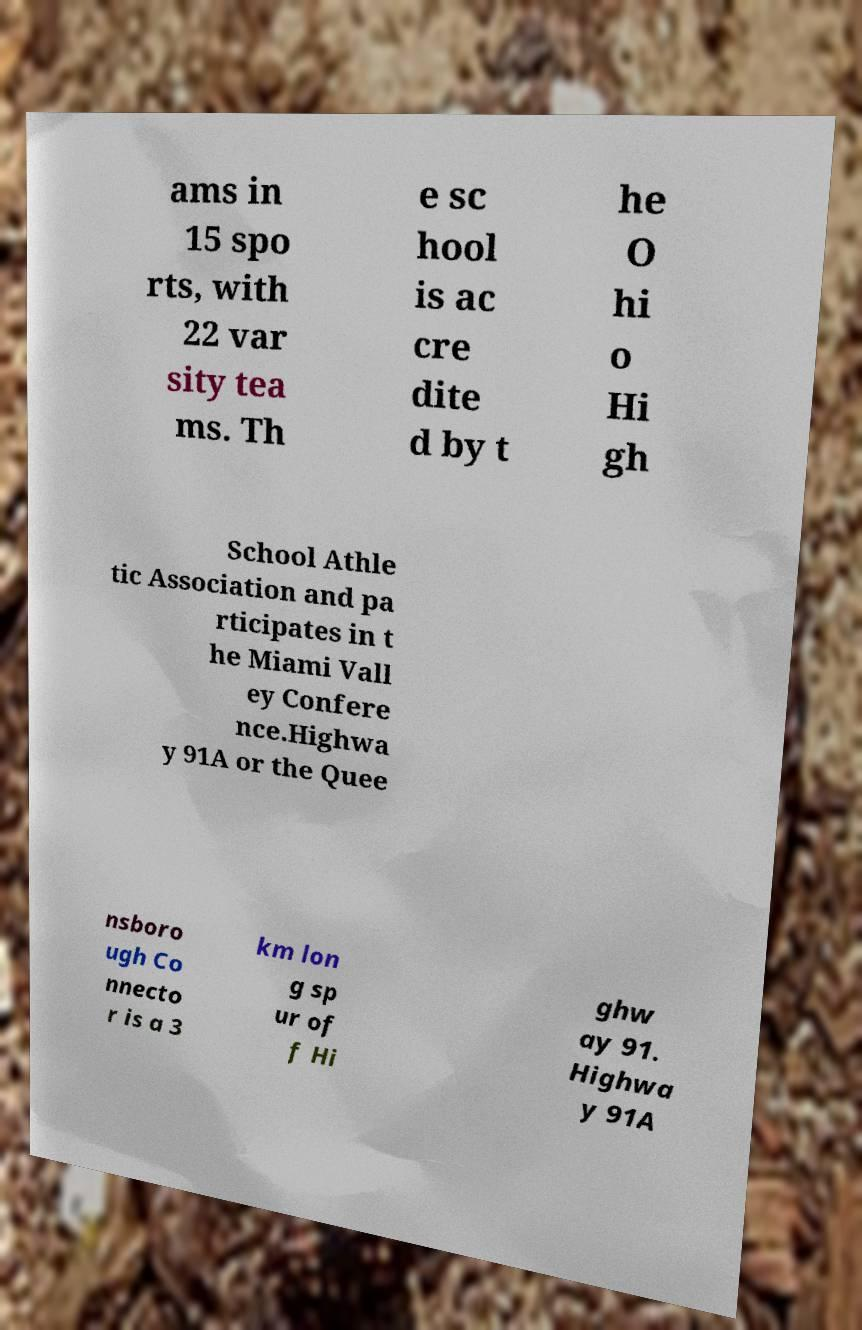What messages or text are displayed in this image? I need them in a readable, typed format. ams in 15 spo rts, with 22 var sity tea ms. Th e sc hool is ac cre dite d by t he O hi o Hi gh School Athle tic Association and pa rticipates in t he Miami Vall ey Confere nce.Highwa y 91A or the Quee nsboro ugh Co nnecto r is a 3 km lon g sp ur of f Hi ghw ay 91. Highwa y 91A 